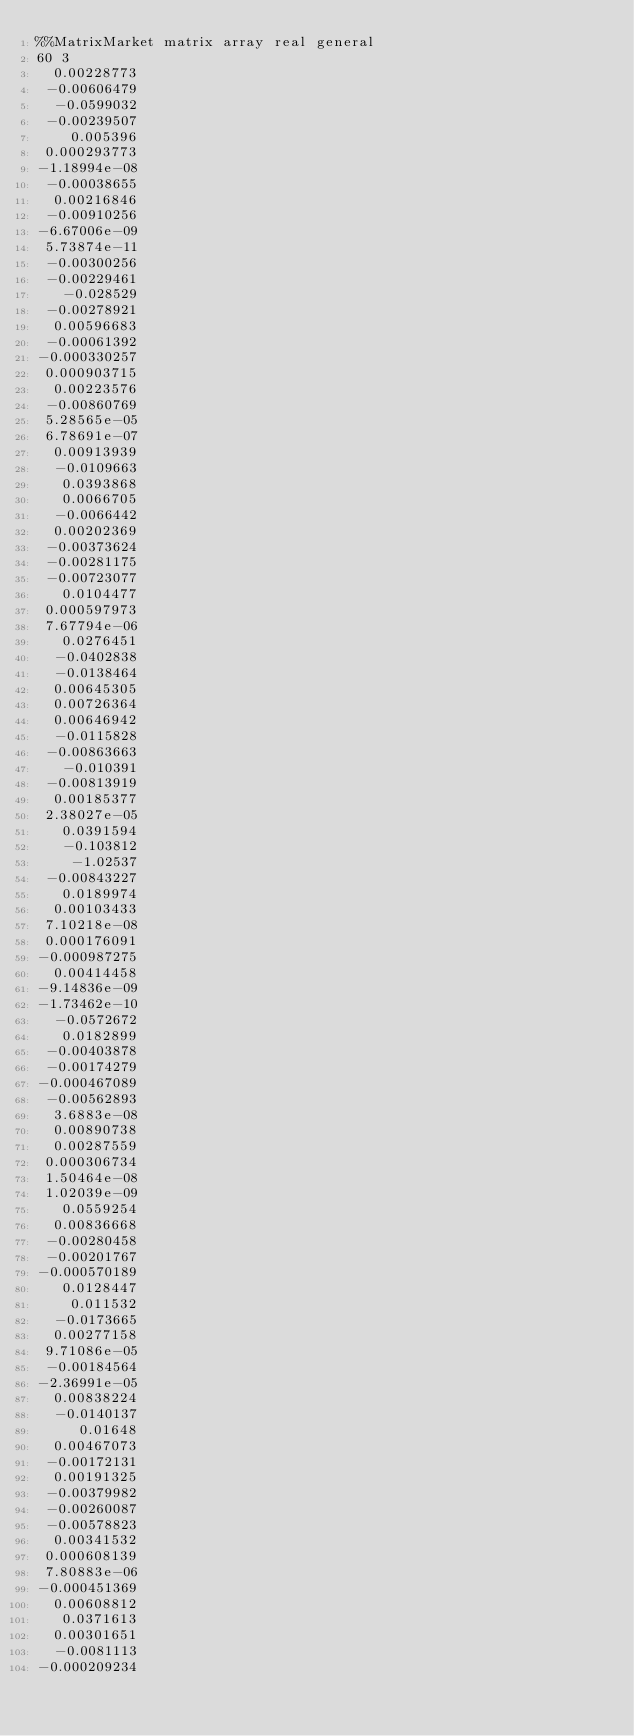Convert code to text. <code><loc_0><loc_0><loc_500><loc_500><_ObjectiveC_>%%MatrixMarket matrix array real general
60 3
  0.00228773
 -0.00606479
  -0.0599032
 -0.00239507
    0.005396
 0.000293773
-1.18994e-08
 -0.00038655
  0.00216846
 -0.00910256
-6.67006e-09
 5.73874e-11
 -0.00300256
 -0.00229461
   -0.028529
 -0.00278921
  0.00596683
 -0.00061392
-0.000330257
 0.000903715
  0.00223576
 -0.00860769
 5.28565e-05
 6.78691e-07
  0.00913939
  -0.0109663
   0.0393868
   0.0066705
  -0.0066442
  0.00202369
 -0.00373624
 -0.00281175
 -0.00723077
   0.0104477
 0.000597973
 7.67794e-06
   0.0276451
  -0.0402838
  -0.0138464
  0.00645305
  0.00726364
  0.00646942
  -0.0115828
 -0.00863663
   -0.010391
 -0.00813919
  0.00185377
 2.38027e-05
   0.0391594
   -0.103812
    -1.02537
 -0.00843227
   0.0189974
  0.00103433
 7.10218e-08
 0.000176091
-0.000987275
  0.00414458
-9.14836e-09
-1.73462e-10
  -0.0572672
   0.0182899
 -0.00403878
 -0.00174279
-0.000467089
 -0.00562893
  3.6883e-08
  0.00890738
  0.00287559
 0.000306734
 1.50464e-08
 1.02039e-09
   0.0559254
  0.00836668
 -0.00280458
 -0.00201767
-0.000570189
   0.0128447
    0.011532
  -0.0173665
  0.00277158
 9.71086e-05
 -0.00184564
-2.36991e-05
  0.00838224
  -0.0140137
     0.01648
  0.00467073
 -0.00172131
  0.00191325
 -0.00379982
 -0.00260087
 -0.00578823
  0.00341532
 0.000608139
 7.80883e-06
-0.000451369
  0.00608812
   0.0371613
  0.00301651
  -0.0081113
-0.000209234</code> 